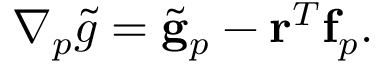Convert formula to latex. <formula><loc_0><loc_0><loc_500><loc_500>\begin{array} { r } { \nabla _ { p } \tilde { g } = \tilde { g } _ { p } - r ^ { T } f _ { p } . } \end{array}</formula> 